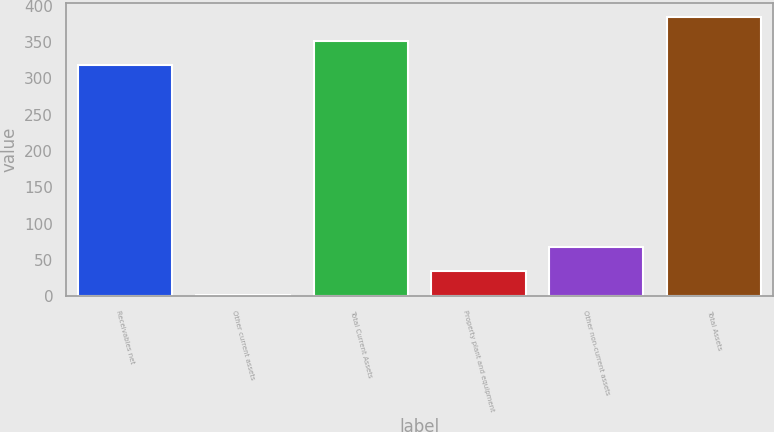<chart> <loc_0><loc_0><loc_500><loc_500><bar_chart><fcel>Receivables net<fcel>Other current assets<fcel>Total Current Assets<fcel>Property plant and equipment<fcel>Other non-current assets<fcel>Total Assets<nl><fcel>319<fcel>2<fcel>352<fcel>35<fcel>68<fcel>385<nl></chart> 